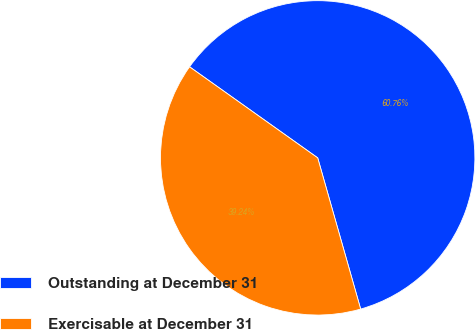Convert chart to OTSL. <chart><loc_0><loc_0><loc_500><loc_500><pie_chart><fcel>Outstanding at December 31<fcel>Exercisable at December 31<nl><fcel>60.76%<fcel>39.24%<nl></chart> 